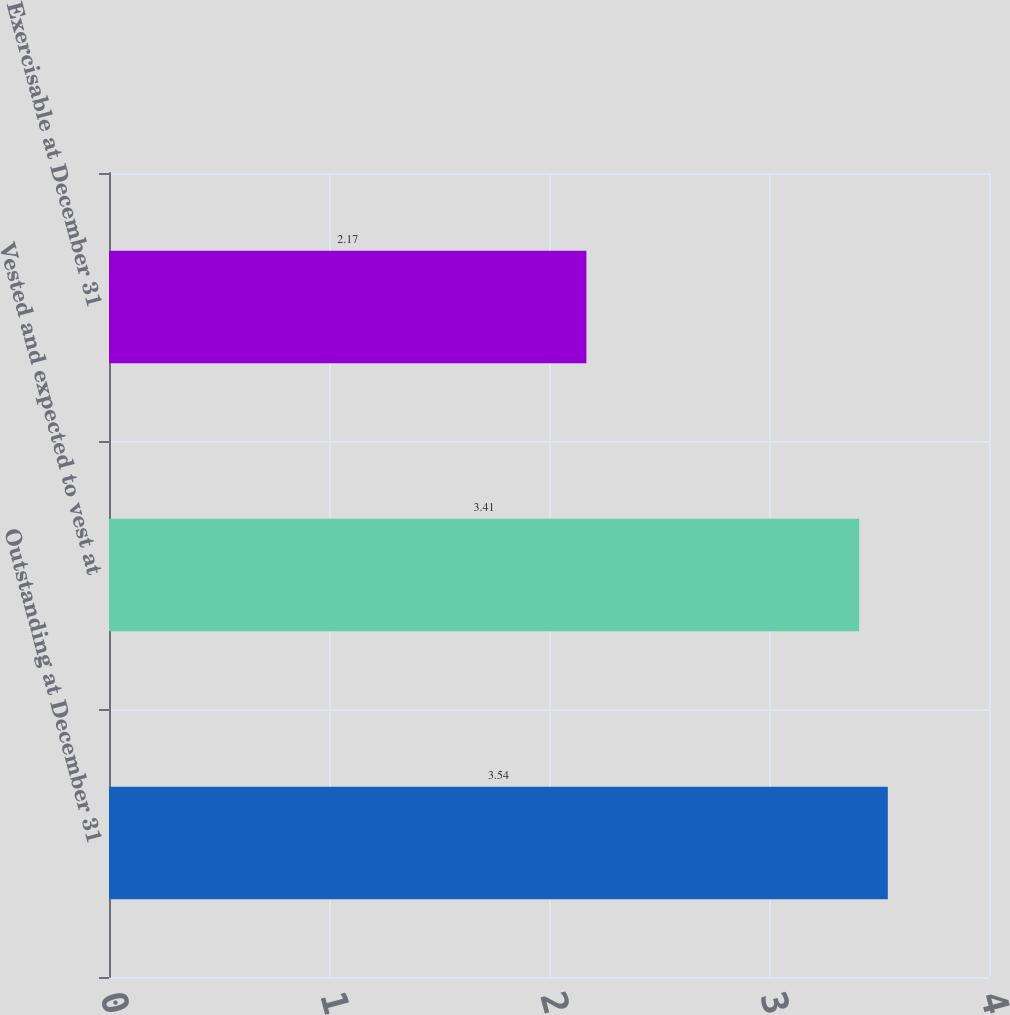Convert chart. <chart><loc_0><loc_0><loc_500><loc_500><bar_chart><fcel>Outstanding at December 31<fcel>Vested and expected to vest at<fcel>Exercisable at December 31<nl><fcel>3.54<fcel>3.41<fcel>2.17<nl></chart> 